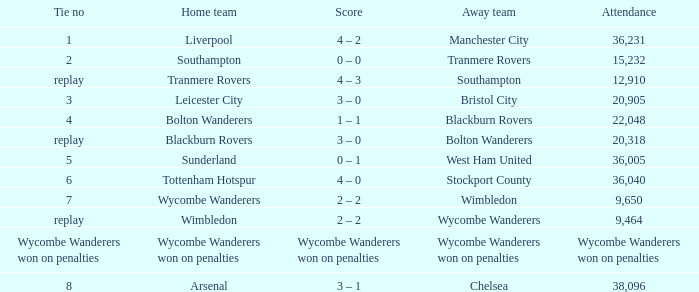What was the attendance for the game where the away team was Stockport County? 36040.0. Write the full table. {'header': ['Tie no', 'Home team', 'Score', 'Away team', 'Attendance'], 'rows': [['1', 'Liverpool', '4 – 2', 'Manchester City', '36,231'], ['2', 'Southampton', '0 – 0', 'Tranmere Rovers', '15,232'], ['replay', 'Tranmere Rovers', '4 – 3', 'Southampton', '12,910'], ['3', 'Leicester City', '3 – 0', 'Bristol City', '20,905'], ['4', 'Bolton Wanderers', '1 – 1', 'Blackburn Rovers', '22,048'], ['replay', 'Blackburn Rovers', '3 – 0', 'Bolton Wanderers', '20,318'], ['5', 'Sunderland', '0 – 1', 'West Ham United', '36,005'], ['6', 'Tottenham Hotspur', '4 – 0', 'Stockport County', '36,040'], ['7', 'Wycombe Wanderers', '2 – 2', 'Wimbledon', '9,650'], ['replay', 'Wimbledon', '2 – 2', 'Wycombe Wanderers', '9,464'], ['Wycombe Wanderers won on penalties', 'Wycombe Wanderers won on penalties', 'Wycombe Wanderers won on penalties', 'Wycombe Wanderers won on penalties', 'Wycombe Wanderers won on penalties'], ['8', 'Arsenal', '3 – 1', 'Chelsea', '38,096']]} 